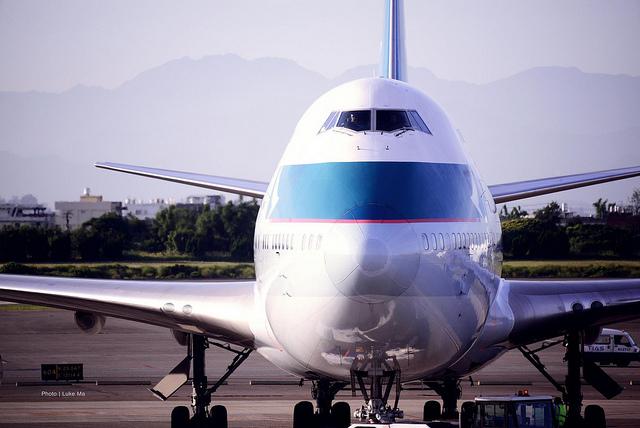Is the weather being overcast with clouds?
Give a very brief answer. Yes. Is this the front or back of the plane?
Short answer required. Front. Do you see any people?
Give a very brief answer. No. 